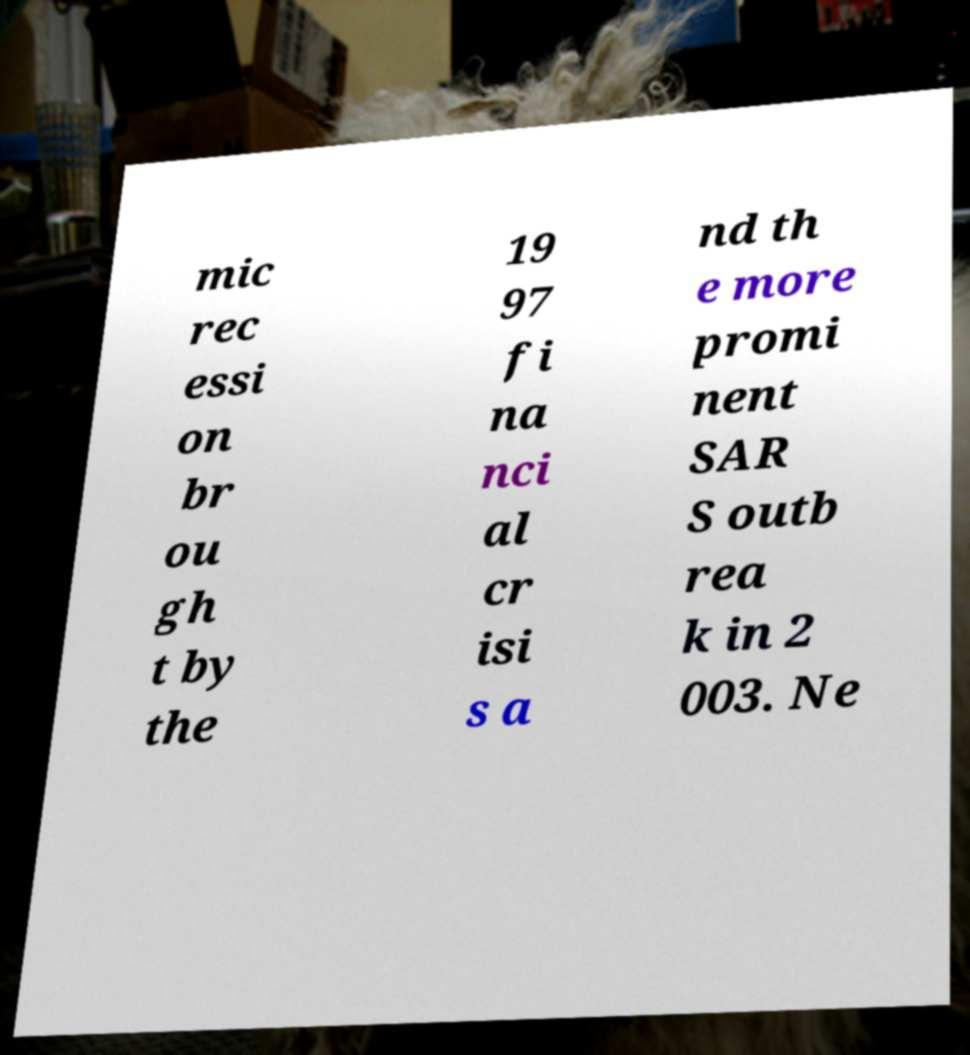For documentation purposes, I need the text within this image transcribed. Could you provide that? mic rec essi on br ou gh t by the 19 97 fi na nci al cr isi s a nd th e more promi nent SAR S outb rea k in 2 003. Ne 